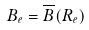Convert formula to latex. <formula><loc_0><loc_0><loc_500><loc_500>B _ { e } = \overline { B } ( R _ { e } )</formula> 